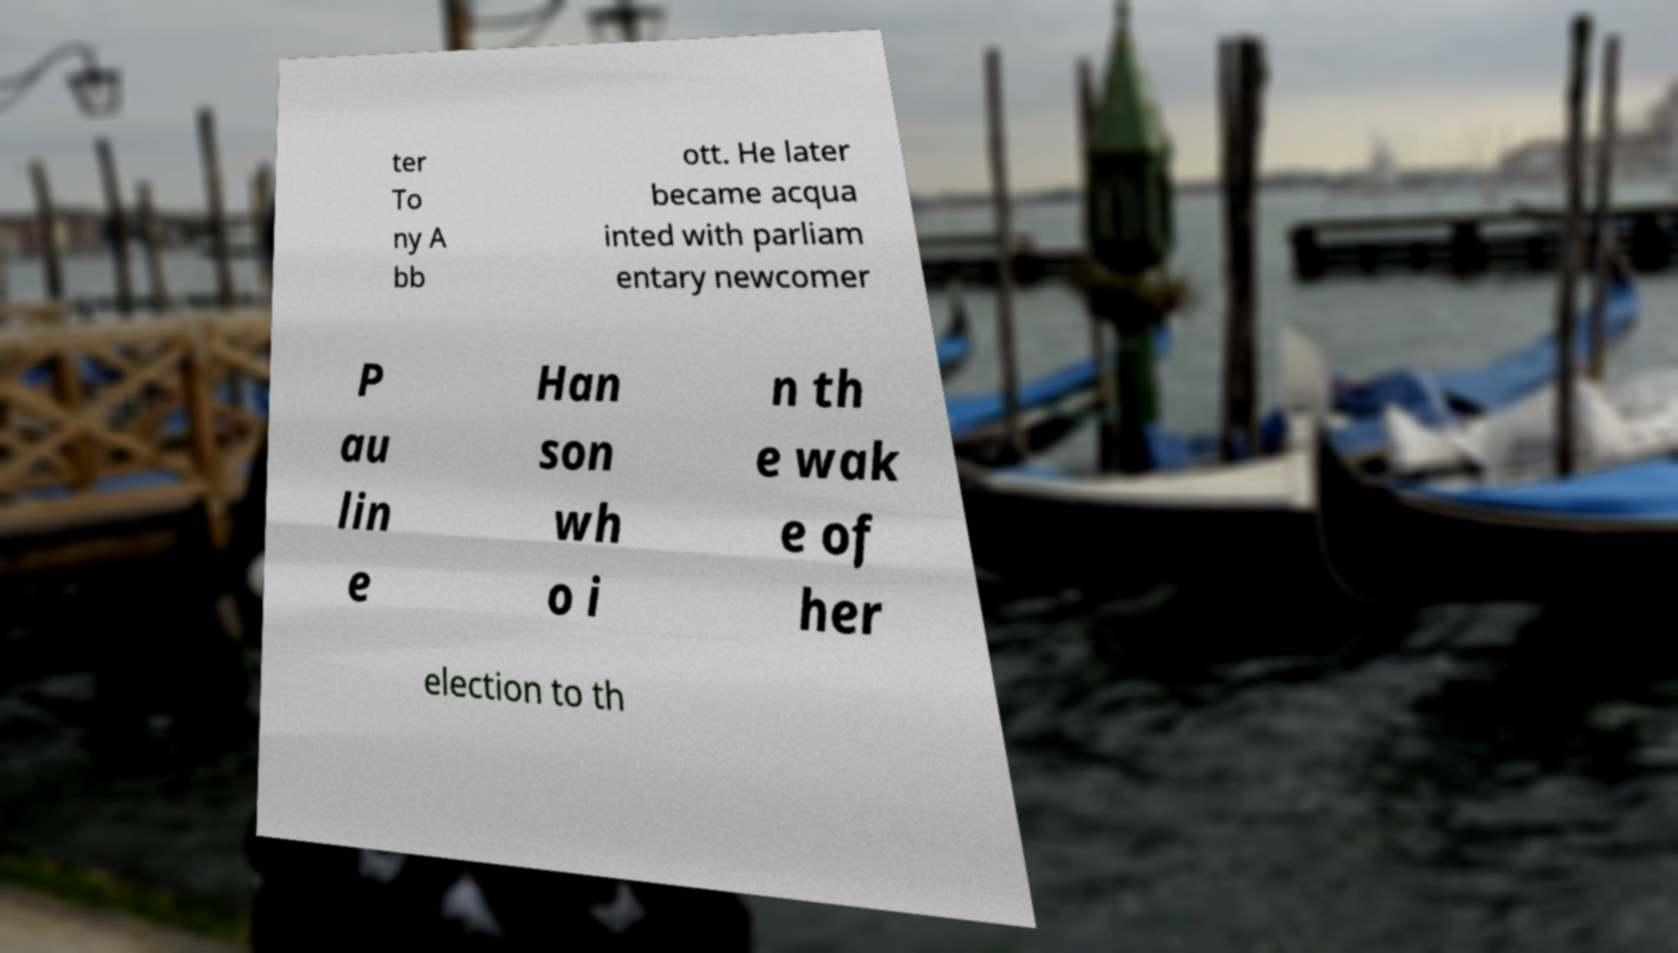Can you accurately transcribe the text from the provided image for me? ter To ny A bb ott. He later became acqua inted with parliam entary newcomer P au lin e Han son wh o i n th e wak e of her election to th 